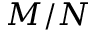Convert formula to latex. <formula><loc_0><loc_0><loc_500><loc_500>M / N</formula> 